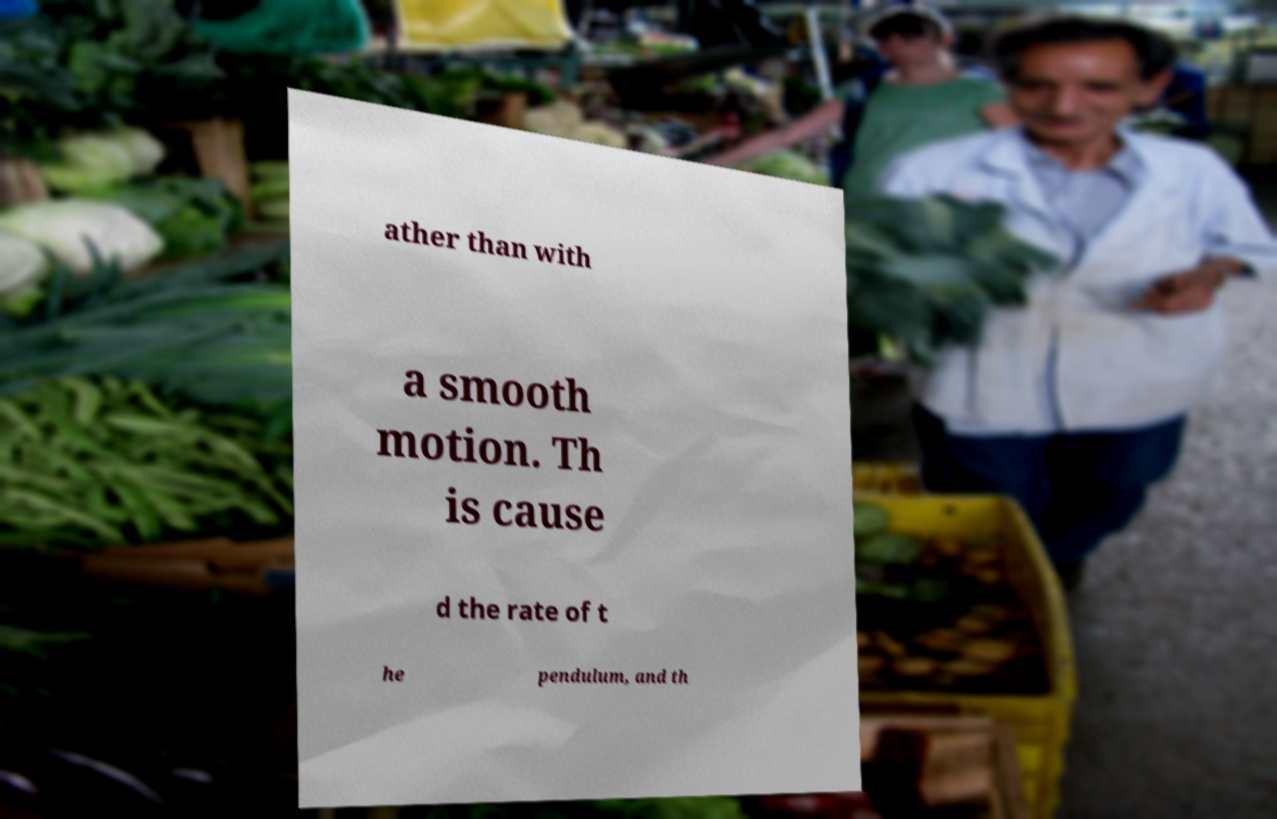Could you assist in decoding the text presented in this image and type it out clearly? ather than with a smooth motion. Th is cause d the rate of t he pendulum, and th 